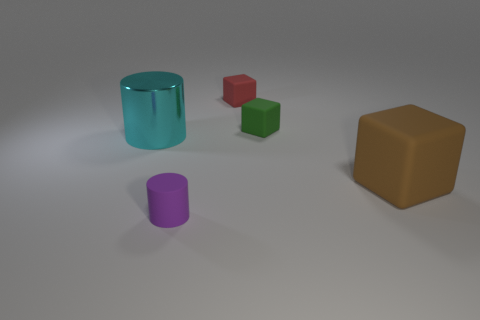There is a object that is in front of the big thing on the right side of the tiny matte thing to the left of the tiny red rubber thing; what is its shape?
Provide a succinct answer. Cylinder. What is the shape of the red thing?
Your answer should be compact. Cube. The rubber object that is the same size as the metallic cylinder is what shape?
Your answer should be very brief. Cube. There is a big thing that is to the right of the big cylinder; is its shape the same as the object that is behind the tiny green rubber cube?
Offer a very short reply. Yes. What number of things are either things that are in front of the large metallic thing or matte cubes left of the large brown thing?
Your answer should be compact. 4. What number of other things are there of the same material as the tiny red thing
Provide a succinct answer. 3. Do the cylinder in front of the big cyan thing and the big cyan thing have the same material?
Ensure brevity in your answer.  No. Is the number of rubber objects that are behind the tiny red matte block greater than the number of green blocks on the left side of the small green block?
Offer a terse response. No. How many things are cubes to the left of the small green thing or tiny yellow rubber blocks?
Your answer should be very brief. 1. What is the shape of the small red thing that is made of the same material as the green object?
Ensure brevity in your answer.  Cube. 